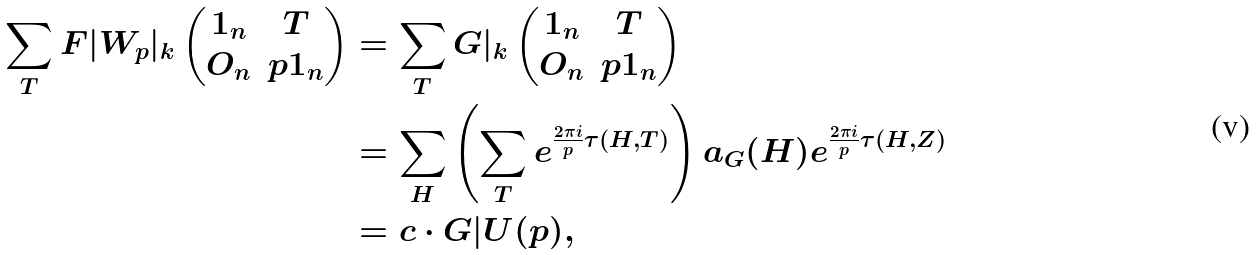Convert formula to latex. <formula><loc_0><loc_0><loc_500><loc_500>\sum _ { T } F | W _ { p } | _ { k } \begin{pmatrix} 1 _ { n } & T \\ O _ { n } & p 1 _ { n } \end{pmatrix} & = \sum _ { T } G | _ { k } \begin{pmatrix} 1 _ { n } & T \\ O _ { n } & p 1 _ { n } \end{pmatrix} \\ & = \sum _ { H } \left ( \sum _ { T } e ^ { \frac { 2 \pi i } { p } \tau ( H , T ) } \right ) a _ { G } ( H ) e ^ { \frac { 2 \pi i } { p } \tau ( H , Z ) } \\ & = c \cdot G | U ( p ) ,</formula> 